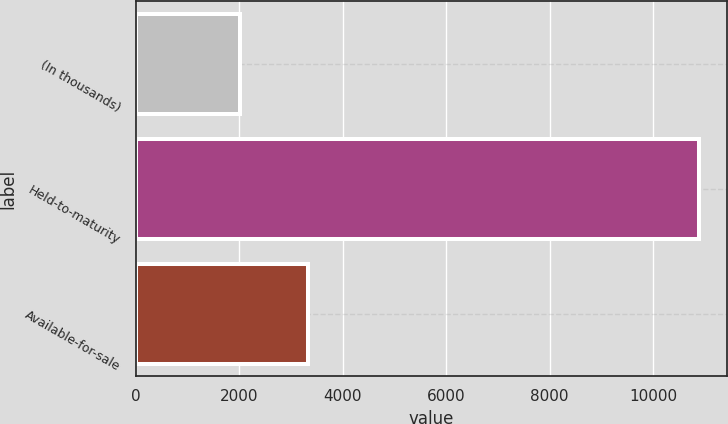Convert chart to OTSL. <chart><loc_0><loc_0><loc_500><loc_500><bar_chart><fcel>(In thousands)<fcel>Held-to-maturity<fcel>Available-for-sale<nl><fcel>2015<fcel>10892<fcel>3326<nl></chart> 